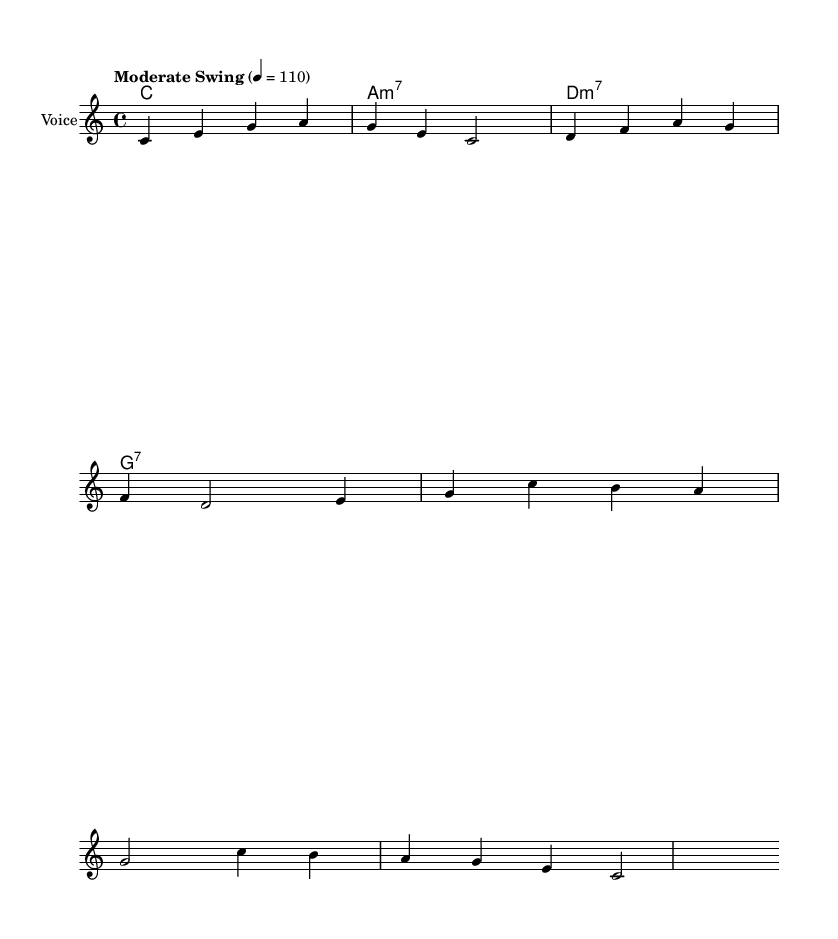What is the key signature of this music? The key signature is indicated at the beginning of the sheet music. It shows that there are no sharps or flats, which confirms the key is C major.
Answer: C major What is the time signature of this music? The time signature is found near the beginning of the staff, showing numbers indicating the number of beats per measure. In this case, it indicates four beats per measure, which is shown as 4/4.
Answer: 4/4 What tempo marking is indicated for this piece? The tempo marking is written above the staff, showing the instruction to play at a moderate swing tempo at a quarter note equal to 110 beats per minute.
Answer: Moderate Swing 4 = 110 What are the chords used in this piece? The harmony section outlines the chords used throughout the piece. They are C major, A minor 7, D minor 7, and G7, arranged in a chord progression.
Answer: C, A minor 7, D minor 7, G7 How many measures are in the melody? By counting the distinct segments divided by vertical lines on the staff, we can see that there are four measures in the melody section.
Answer: 4 What musical style does this piece represent? Given the structure, swing feel, and lyrical content focusing on resilience, this piece can be categorized as a jazz standard.
Answer: Jazz standard 